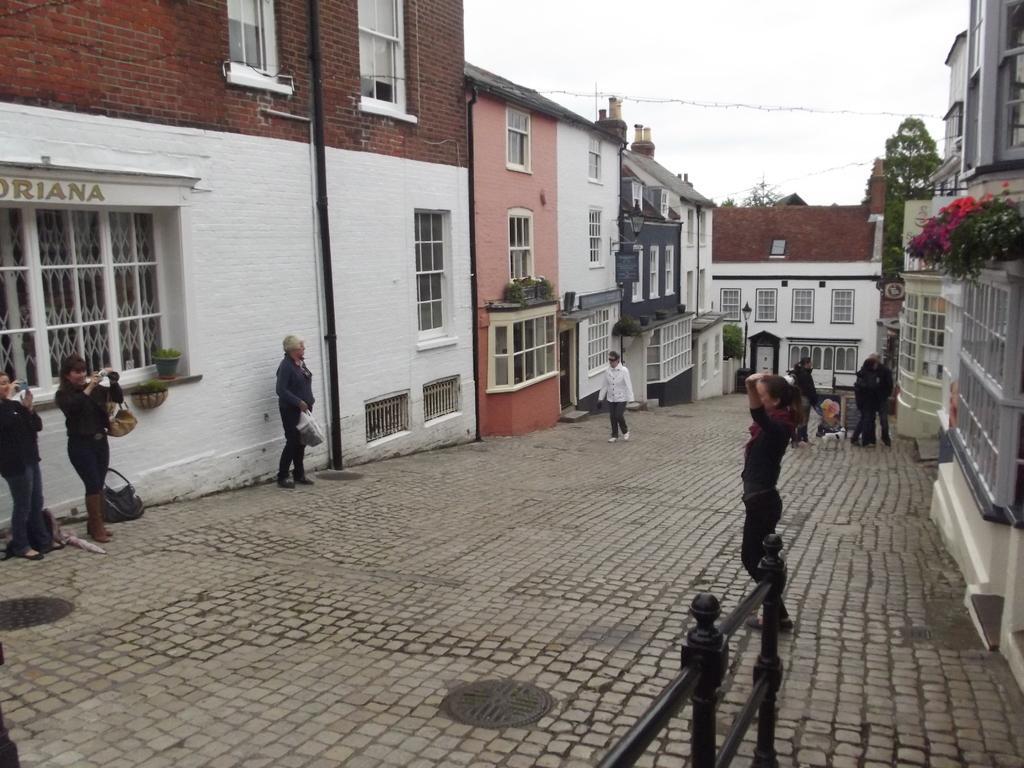Please provide a concise description of this image. On the left side 3 women are standing, in the middle a person is walking, this person wore a white color coat. There are houses on either side of this street. At the top it is the sky. 